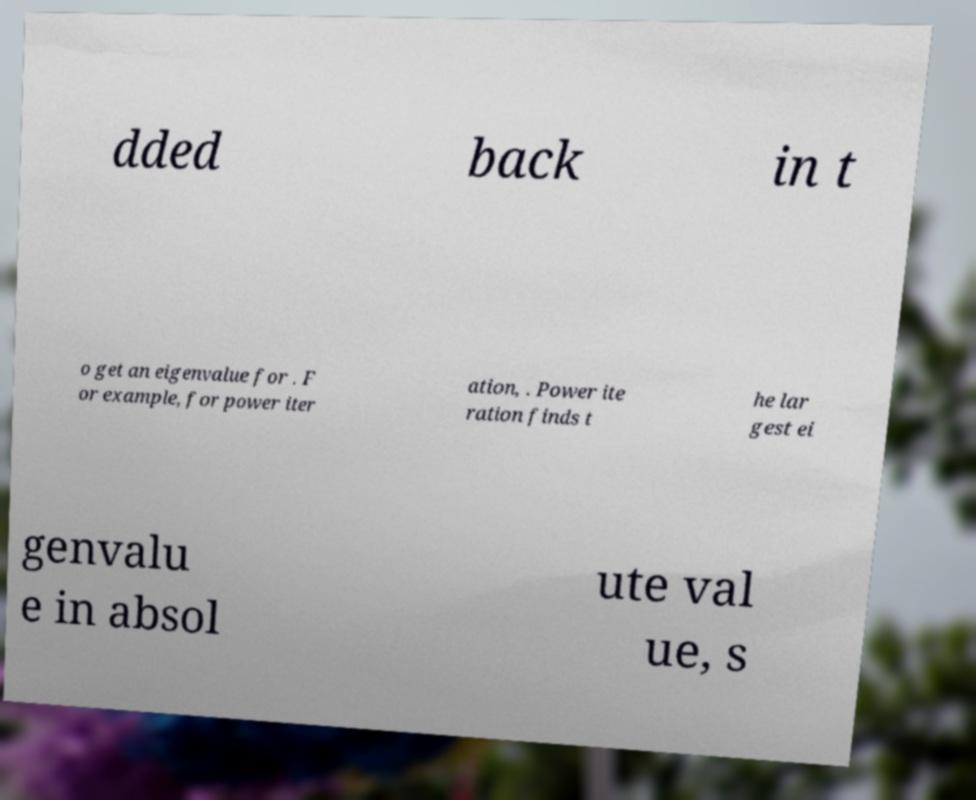What messages or text are displayed in this image? I need them in a readable, typed format. dded back in t o get an eigenvalue for . F or example, for power iter ation, . Power ite ration finds t he lar gest ei genvalu e in absol ute val ue, s 